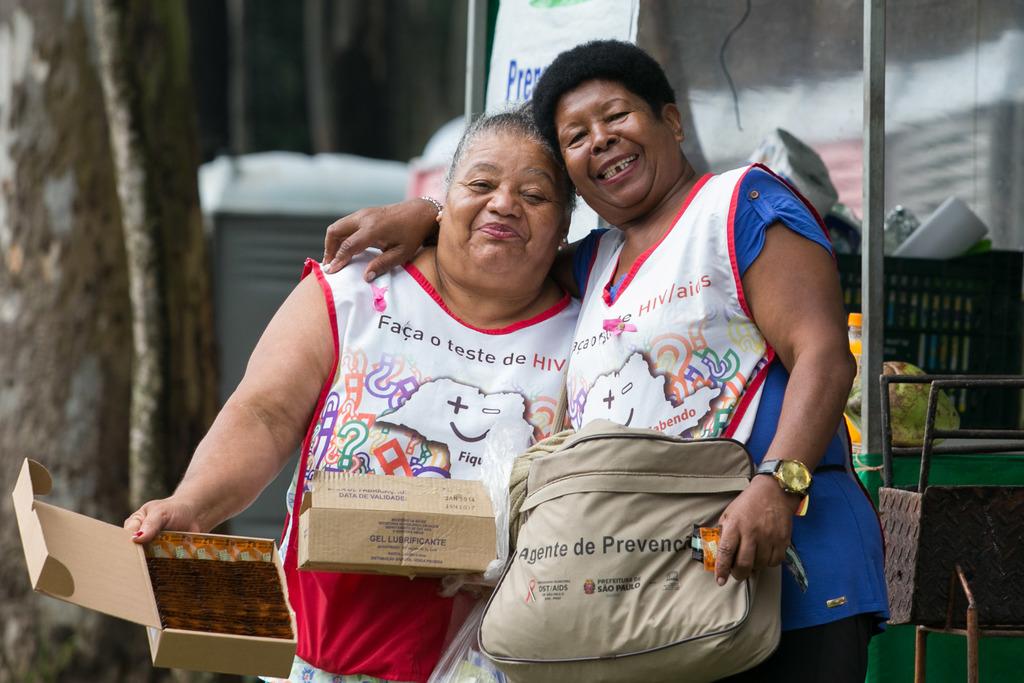What disease is their shirt focused on?
Offer a very short reply. Hiv. How many words are on the shirt of the woman to the left?
Your answer should be compact. 5. 